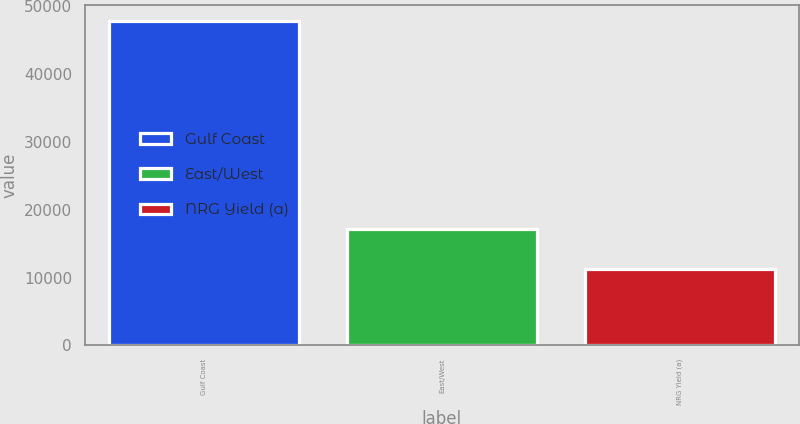Convert chart to OTSL. <chart><loc_0><loc_0><loc_500><loc_500><bar_chart><fcel>Gulf Coast<fcel>East/West<fcel>NRG Yield (a)<nl><fcel>47827<fcel>17114<fcel>11230<nl></chart> 